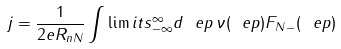Convert formula to latex. <formula><loc_0><loc_0><loc_500><loc_500>j = \frac { 1 } { 2 e R _ { n N } } \int \lim i t s _ { - \infty } ^ { \infty } d \ e p \, \nu ( \ e p ) F _ { N - } ( \ e p )</formula> 